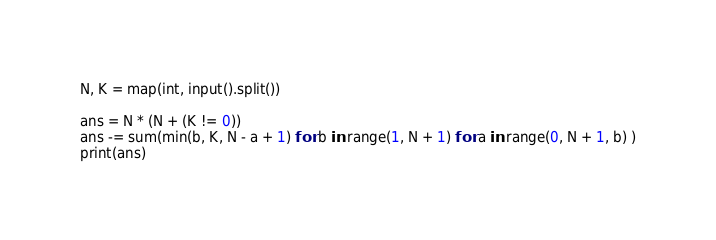<code> <loc_0><loc_0><loc_500><loc_500><_Python_>N, K = map(int, input().split())

ans = N * (N + (K != 0))
ans -= sum(min(b, K, N - a + 1) for b in range(1, N + 1) for a in range(0, N + 1, b) )
print(ans)</code> 